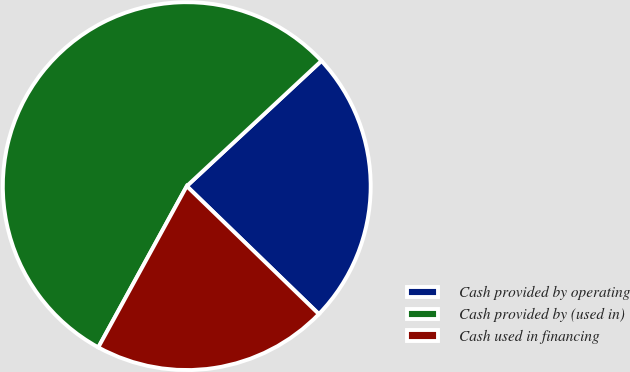Convert chart to OTSL. <chart><loc_0><loc_0><loc_500><loc_500><pie_chart><fcel>Cash provided by operating<fcel>Cash provided by (used in)<fcel>Cash used in financing<nl><fcel>24.17%<fcel>55.09%<fcel>20.74%<nl></chart> 